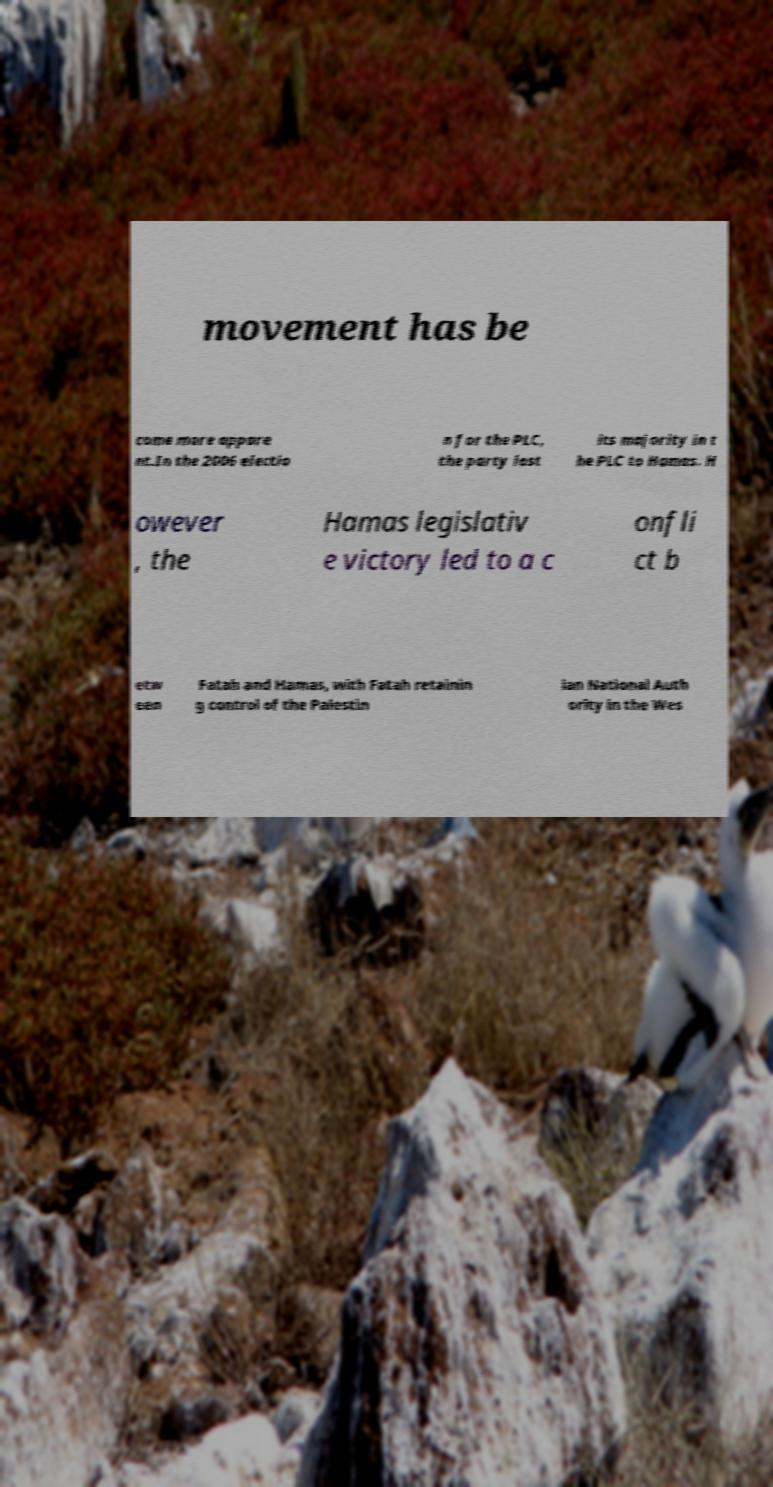What messages or text are displayed in this image? I need them in a readable, typed format. movement has be come more appare nt.In the 2006 electio n for the PLC, the party lost its majority in t he PLC to Hamas. H owever , the Hamas legislativ e victory led to a c onfli ct b etw een Fatah and Hamas, with Fatah retainin g control of the Palestin ian National Auth ority in the Wes 